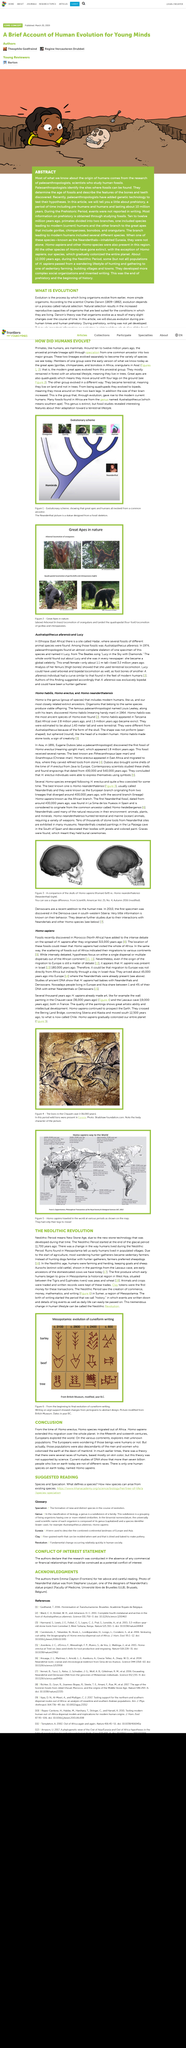Indicate a few pertinent items in this graphic. The title of the article is "Homo sapiens. In 2010, the first Denisovan specimen was discovered. The lions were painted in the Chauvet cave approximately 36,000 years ago, as depicted in the photograph. Eugene Dubois discovered the first fossil of Homo erectus. The above picture portrays the evolution of cuneiform writing. 